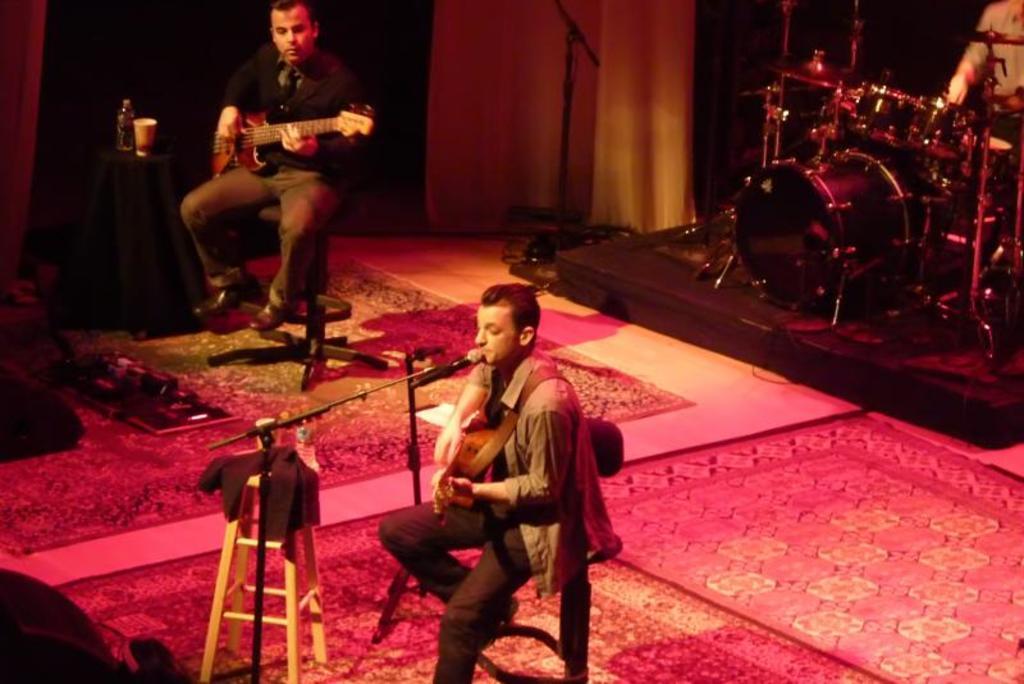Please provide a concise description of this image. They are sitting on a chair. They are playing musical instruments. 